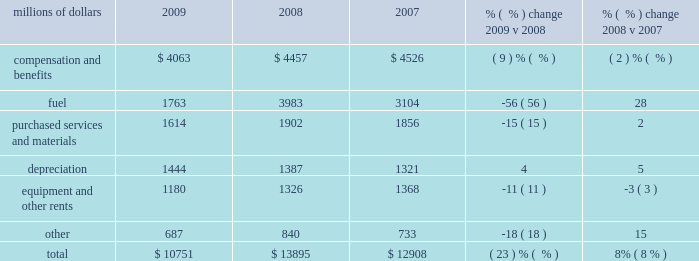Intermodal 2013 decreased volumes and fuel surcharges reduced freight revenue from intermodal shipments in 2009 versus 2008 .
Volume from international traffic decreased 24% ( 24 % ) in 2009 compared to 2008 , reflecting economic conditions , continued weak imports from asia , and diversions to non-uprr served ports .
Additionally , continued weakness in the domestic housing and automotive sectors translated into weak demand in large sectors of the international intermodal market , which also contributed to the volume decline .
Conversely , domestic traffic increased 8% ( 8 % ) in 2009 compared to 2008 .
A new contract with hub group , inc. , which included additional shipments , was executed in the second quarter of 2009 and more than offset the impact of weak market conditions in the second half of 2009 .
Price increases and fuel surcharges generated higher revenue in 2008 , partially offset by lower volume levels .
International traffic declined 11% ( 11 % ) in 2008 , reflecting continued softening of imports from china and the loss of a customer contract .
Notably , the peak intermodal shipping season , which usually starts in the third quarter , was particularly weak in 2008 .
Additionally , continued weakness in domestic housing and automotive sectors translated into weak demand in large sectors of the international intermodal market , which also contributed to lower volumes .
Domestic traffic declined 3% ( 3 % ) in 2008 due to the loss of a customer contract and lower volumes from less-than-truckload shippers .
Additionally , the flood-related embargo on traffic in the midwest during the second quarter hindered intermodal volume levels in 2008 .
Mexico business 2013 each of our commodity groups include revenue from shipments to and from mexico .
Revenue from mexico business decreased 26% ( 26 % ) in 2009 versus 2008 to $ 1.2 billion .
Volume declined in five of our six commodity groups , down 19% ( 19 % ) in 2009 , driven by 32% ( 32 % ) and 24% ( 24 % ) reductions in industrial products and automotive shipments , respectively .
Conversely , energy shipments increased 9% ( 9 % ) in 2009 versus 2008 , partially offsetting these declines .
Revenue from mexico business increased 13% ( 13 % ) to $ 1.6 billion in 2008 compared to 2007 .
Price improvements and fuel surcharges contributed to these increases , partially offset by a 4% ( 4 % ) decline in volume in 2008 compared to 2007 .
Operating expenses millions of dollars 2009 2008 2007 % (  % ) change 2009 v 2008 % (  % ) change 2008 v 2007 .
2009 intermodal revenue international domestic .
What was the change in millions of compensation and benefits from 2008 to 2009? 
Computations: (4063 - 4457)
Answer: -394.0. 